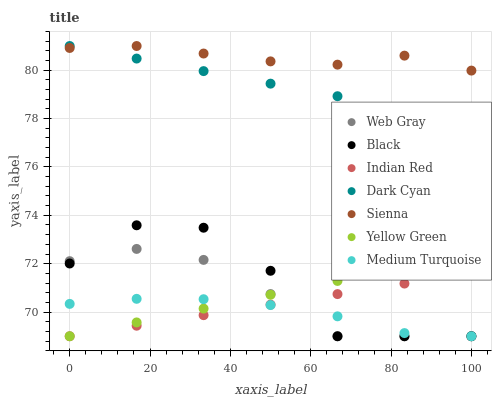Does Medium Turquoise have the minimum area under the curve?
Answer yes or no. Yes. Does Sienna have the maximum area under the curve?
Answer yes or no. Yes. Does Web Gray have the minimum area under the curve?
Answer yes or no. No. Does Web Gray have the maximum area under the curve?
Answer yes or no. No. Is Indian Red the smoothest?
Answer yes or no. Yes. Is Black the roughest?
Answer yes or no. Yes. Is Web Gray the smoothest?
Answer yes or no. No. Is Web Gray the roughest?
Answer yes or no. No. Does Medium Turquoise have the lowest value?
Answer yes or no. Yes. Does Sienna have the lowest value?
Answer yes or no. No. Does Dark Cyan have the highest value?
Answer yes or no. Yes. Does Web Gray have the highest value?
Answer yes or no. No. Is Medium Turquoise less than Sienna?
Answer yes or no. Yes. Is Sienna greater than Indian Red?
Answer yes or no. Yes. Does Sienna intersect Dark Cyan?
Answer yes or no. Yes. Is Sienna less than Dark Cyan?
Answer yes or no. No. Is Sienna greater than Dark Cyan?
Answer yes or no. No. Does Medium Turquoise intersect Sienna?
Answer yes or no. No. 